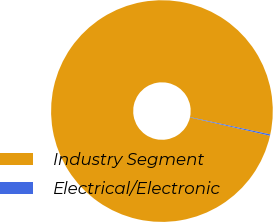Convert chart to OTSL. <chart><loc_0><loc_0><loc_500><loc_500><pie_chart><fcel>Industry Segment<fcel>Electrical/Electronic<nl><fcel>99.8%<fcel>0.2%<nl></chart> 